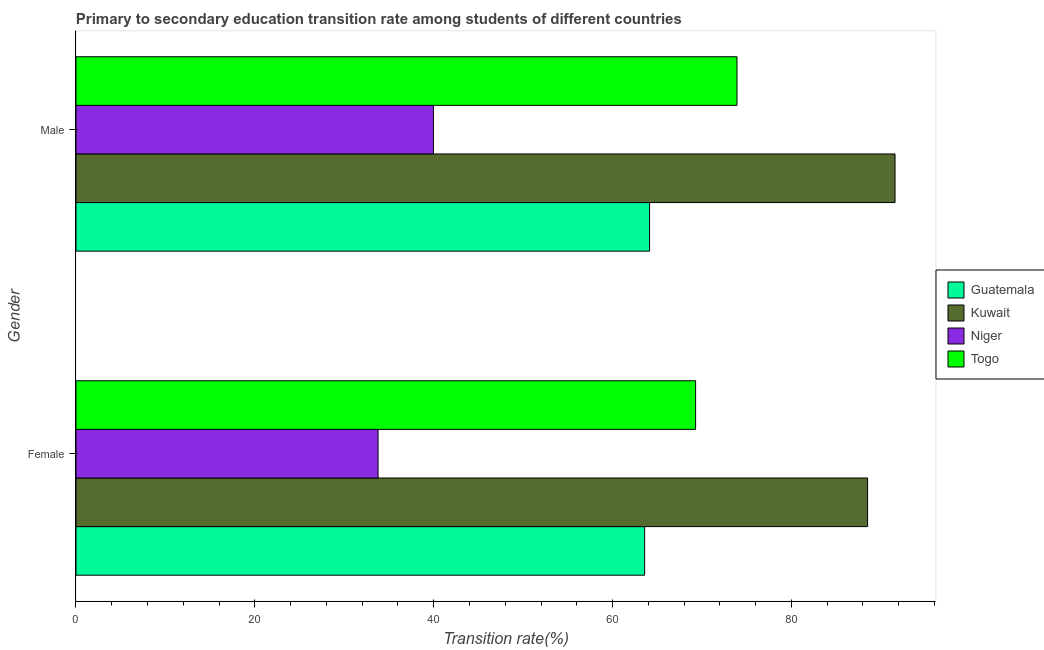How many different coloured bars are there?
Offer a terse response. 4. How many groups of bars are there?
Provide a short and direct response. 2. What is the label of the 1st group of bars from the top?
Ensure brevity in your answer.  Male. What is the transition rate among female students in Togo?
Your response must be concise. 69.29. Across all countries, what is the maximum transition rate among female students?
Make the answer very short. 88.52. Across all countries, what is the minimum transition rate among male students?
Offer a very short reply. 39.97. In which country was the transition rate among female students maximum?
Offer a terse response. Kuwait. In which country was the transition rate among female students minimum?
Your answer should be compact. Niger. What is the total transition rate among female students in the graph?
Your answer should be compact. 255.17. What is the difference between the transition rate among male students in Togo and that in Guatemala?
Your answer should be very brief. 9.77. What is the difference between the transition rate among male students in Kuwait and the transition rate among female students in Togo?
Your answer should be very brief. 22.3. What is the average transition rate among female students per country?
Offer a very short reply. 63.79. What is the difference between the transition rate among female students and transition rate among male students in Kuwait?
Your response must be concise. -3.07. What is the ratio of the transition rate among female students in Niger to that in Togo?
Your answer should be very brief. 0.49. In how many countries, is the transition rate among male students greater than the average transition rate among male students taken over all countries?
Offer a very short reply. 2. What does the 1st bar from the top in Male represents?
Your response must be concise. Togo. What does the 2nd bar from the bottom in Male represents?
Give a very brief answer. Kuwait. How many bars are there?
Give a very brief answer. 8. How many countries are there in the graph?
Offer a very short reply. 4. Does the graph contain any zero values?
Keep it short and to the point. No. How many legend labels are there?
Make the answer very short. 4. What is the title of the graph?
Give a very brief answer. Primary to secondary education transition rate among students of different countries. Does "Small states" appear as one of the legend labels in the graph?
Your answer should be compact. No. What is the label or title of the X-axis?
Give a very brief answer. Transition rate(%). What is the Transition rate(%) of Guatemala in Female?
Offer a very short reply. 63.59. What is the Transition rate(%) of Kuwait in Female?
Offer a very short reply. 88.52. What is the Transition rate(%) of Niger in Female?
Your answer should be very brief. 33.78. What is the Transition rate(%) in Togo in Female?
Your answer should be compact. 69.29. What is the Transition rate(%) in Guatemala in Male?
Ensure brevity in your answer.  64.14. What is the Transition rate(%) of Kuwait in Male?
Offer a terse response. 91.58. What is the Transition rate(%) in Niger in Male?
Make the answer very short. 39.97. What is the Transition rate(%) of Togo in Male?
Provide a succinct answer. 73.91. Across all Gender, what is the maximum Transition rate(%) of Guatemala?
Provide a short and direct response. 64.14. Across all Gender, what is the maximum Transition rate(%) in Kuwait?
Your answer should be compact. 91.58. Across all Gender, what is the maximum Transition rate(%) in Niger?
Your answer should be compact. 39.97. Across all Gender, what is the maximum Transition rate(%) in Togo?
Offer a very short reply. 73.91. Across all Gender, what is the minimum Transition rate(%) of Guatemala?
Give a very brief answer. 63.59. Across all Gender, what is the minimum Transition rate(%) in Kuwait?
Ensure brevity in your answer.  88.52. Across all Gender, what is the minimum Transition rate(%) of Niger?
Your answer should be very brief. 33.78. Across all Gender, what is the minimum Transition rate(%) of Togo?
Your answer should be compact. 69.29. What is the total Transition rate(%) in Guatemala in the graph?
Give a very brief answer. 127.72. What is the total Transition rate(%) in Kuwait in the graph?
Your answer should be very brief. 180.1. What is the total Transition rate(%) of Niger in the graph?
Make the answer very short. 73.75. What is the total Transition rate(%) of Togo in the graph?
Keep it short and to the point. 143.2. What is the difference between the Transition rate(%) in Guatemala in Female and that in Male?
Provide a succinct answer. -0.55. What is the difference between the Transition rate(%) of Kuwait in Female and that in Male?
Your response must be concise. -3.07. What is the difference between the Transition rate(%) in Niger in Female and that in Male?
Offer a terse response. -6.19. What is the difference between the Transition rate(%) of Togo in Female and that in Male?
Give a very brief answer. -4.63. What is the difference between the Transition rate(%) in Guatemala in Female and the Transition rate(%) in Kuwait in Male?
Your answer should be very brief. -28. What is the difference between the Transition rate(%) in Guatemala in Female and the Transition rate(%) in Niger in Male?
Give a very brief answer. 23.62. What is the difference between the Transition rate(%) in Guatemala in Female and the Transition rate(%) in Togo in Male?
Offer a terse response. -10.33. What is the difference between the Transition rate(%) of Kuwait in Female and the Transition rate(%) of Niger in Male?
Provide a short and direct response. 48.55. What is the difference between the Transition rate(%) in Kuwait in Female and the Transition rate(%) in Togo in Male?
Your answer should be compact. 14.6. What is the difference between the Transition rate(%) in Niger in Female and the Transition rate(%) in Togo in Male?
Ensure brevity in your answer.  -40.13. What is the average Transition rate(%) of Guatemala per Gender?
Offer a very short reply. 63.86. What is the average Transition rate(%) in Kuwait per Gender?
Your response must be concise. 90.05. What is the average Transition rate(%) in Niger per Gender?
Provide a succinct answer. 36.87. What is the average Transition rate(%) of Togo per Gender?
Provide a succinct answer. 71.6. What is the difference between the Transition rate(%) in Guatemala and Transition rate(%) in Kuwait in Female?
Offer a very short reply. -24.93. What is the difference between the Transition rate(%) in Guatemala and Transition rate(%) in Niger in Female?
Your answer should be very brief. 29.81. What is the difference between the Transition rate(%) in Guatemala and Transition rate(%) in Togo in Female?
Give a very brief answer. -5.7. What is the difference between the Transition rate(%) in Kuwait and Transition rate(%) in Niger in Female?
Give a very brief answer. 54.74. What is the difference between the Transition rate(%) of Kuwait and Transition rate(%) of Togo in Female?
Your answer should be compact. 19.23. What is the difference between the Transition rate(%) in Niger and Transition rate(%) in Togo in Female?
Provide a succinct answer. -35.51. What is the difference between the Transition rate(%) of Guatemala and Transition rate(%) of Kuwait in Male?
Ensure brevity in your answer.  -27.45. What is the difference between the Transition rate(%) in Guatemala and Transition rate(%) in Niger in Male?
Offer a terse response. 24.17. What is the difference between the Transition rate(%) in Guatemala and Transition rate(%) in Togo in Male?
Your response must be concise. -9.78. What is the difference between the Transition rate(%) of Kuwait and Transition rate(%) of Niger in Male?
Provide a short and direct response. 51.62. What is the difference between the Transition rate(%) of Kuwait and Transition rate(%) of Togo in Male?
Offer a very short reply. 17.67. What is the difference between the Transition rate(%) of Niger and Transition rate(%) of Togo in Male?
Offer a very short reply. -33.95. What is the ratio of the Transition rate(%) of Guatemala in Female to that in Male?
Your answer should be compact. 0.99. What is the ratio of the Transition rate(%) of Kuwait in Female to that in Male?
Your answer should be compact. 0.97. What is the ratio of the Transition rate(%) of Niger in Female to that in Male?
Offer a very short reply. 0.85. What is the ratio of the Transition rate(%) of Togo in Female to that in Male?
Offer a very short reply. 0.94. What is the difference between the highest and the second highest Transition rate(%) in Guatemala?
Your answer should be very brief. 0.55. What is the difference between the highest and the second highest Transition rate(%) of Kuwait?
Keep it short and to the point. 3.07. What is the difference between the highest and the second highest Transition rate(%) of Niger?
Make the answer very short. 6.19. What is the difference between the highest and the second highest Transition rate(%) of Togo?
Provide a succinct answer. 4.63. What is the difference between the highest and the lowest Transition rate(%) of Guatemala?
Your response must be concise. 0.55. What is the difference between the highest and the lowest Transition rate(%) of Kuwait?
Your answer should be very brief. 3.07. What is the difference between the highest and the lowest Transition rate(%) of Niger?
Offer a terse response. 6.19. What is the difference between the highest and the lowest Transition rate(%) in Togo?
Keep it short and to the point. 4.63. 